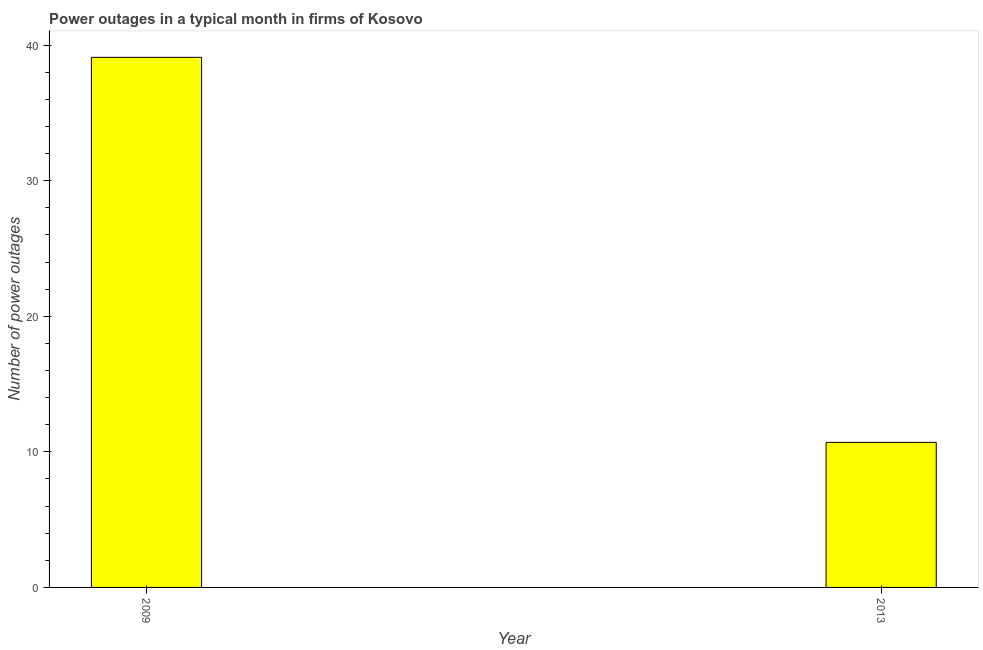Does the graph contain grids?
Provide a short and direct response. No. What is the title of the graph?
Offer a very short reply. Power outages in a typical month in firms of Kosovo. What is the label or title of the Y-axis?
Keep it short and to the point. Number of power outages. What is the number of power outages in 2013?
Provide a short and direct response. 10.7. Across all years, what is the maximum number of power outages?
Ensure brevity in your answer.  39.1. In which year was the number of power outages maximum?
Your answer should be compact. 2009. In which year was the number of power outages minimum?
Offer a very short reply. 2013. What is the sum of the number of power outages?
Ensure brevity in your answer.  49.8. What is the difference between the number of power outages in 2009 and 2013?
Make the answer very short. 28.4. What is the average number of power outages per year?
Keep it short and to the point. 24.9. What is the median number of power outages?
Provide a succinct answer. 24.9. What is the ratio of the number of power outages in 2009 to that in 2013?
Your answer should be very brief. 3.65. Is the number of power outages in 2009 less than that in 2013?
Make the answer very short. No. How many bars are there?
Provide a succinct answer. 2. How many years are there in the graph?
Provide a short and direct response. 2. What is the difference between two consecutive major ticks on the Y-axis?
Ensure brevity in your answer.  10. What is the Number of power outages in 2009?
Your answer should be very brief. 39.1. What is the Number of power outages of 2013?
Ensure brevity in your answer.  10.7. What is the difference between the Number of power outages in 2009 and 2013?
Your answer should be very brief. 28.4. What is the ratio of the Number of power outages in 2009 to that in 2013?
Give a very brief answer. 3.65. 